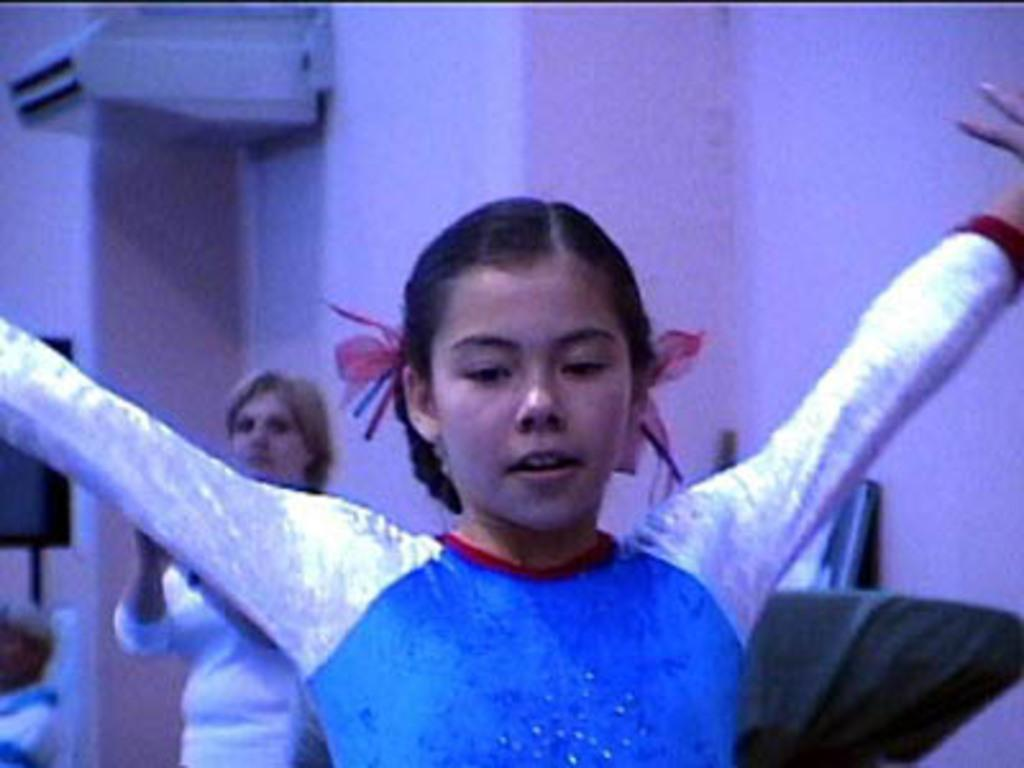Who is the main subject in the foreground of the image? There is a girl in the foreground of the image. Can you describe the person in the background of the image? There is a woman in the background of the image. What is a prominent feature in the image? There is a wall in the image. What piece of furniture is visible in the image? There is a chair to the right side of the image. What type of beast can be seen interacting with the girl in the image? There is no beast present in the image; it features a girl and a woman in different parts of the image. 